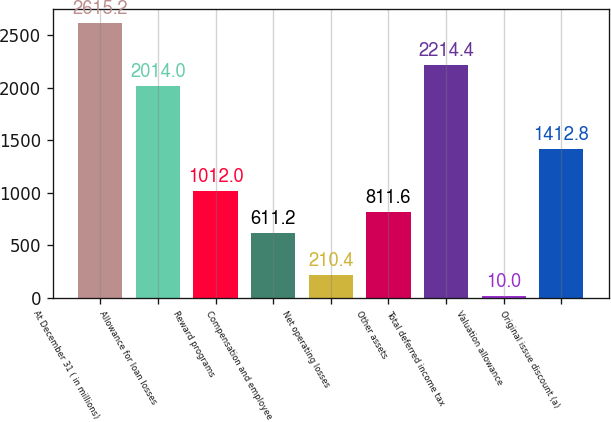<chart> <loc_0><loc_0><loc_500><loc_500><bar_chart><fcel>At December 31 ( in millions)<fcel>Allowance for loan losses<fcel>Reward programs<fcel>Compensation and employee<fcel>Net operating losses<fcel>Other assets<fcel>Total deferred income tax<fcel>Valuation allowance<fcel>Original issue discount (a)<nl><fcel>2615.2<fcel>2014<fcel>1012<fcel>611.2<fcel>210.4<fcel>811.6<fcel>2214.4<fcel>10<fcel>1412.8<nl></chart> 